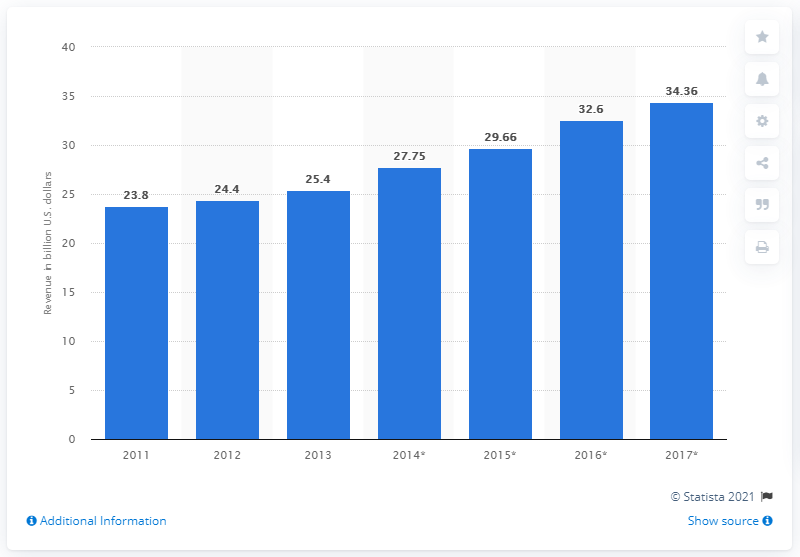Give some essential details in this illustration. By 2017, global revenues for ERP software are expected to reach a projected $34.36 billion, according to industry predictions. 